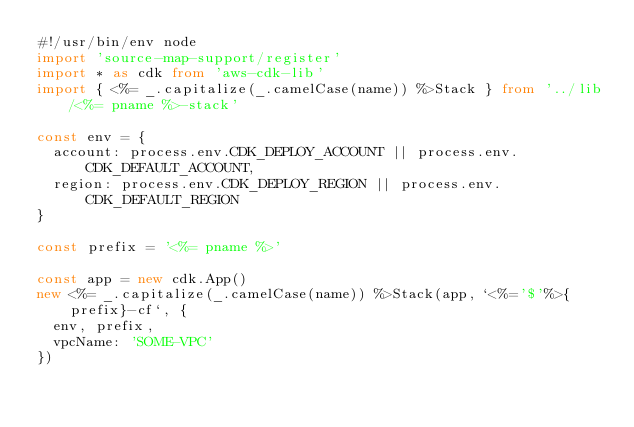<code> <loc_0><loc_0><loc_500><loc_500><_TypeScript_>#!/usr/bin/env node
import 'source-map-support/register'
import * as cdk from 'aws-cdk-lib'
import { <%= _.capitalize(_.camelCase(name)) %>Stack } from '../lib/<%= pname %>-stack'

const env = {
  account: process.env.CDK_DEPLOY_ACCOUNT || process.env.CDK_DEFAULT_ACCOUNT,
  region: process.env.CDK_DEPLOY_REGION || process.env.CDK_DEFAULT_REGION
}

const prefix = '<%= pname %>'

const app = new cdk.App()
new <%= _.capitalize(_.camelCase(name)) %>Stack(app, `<%='$'%>{prefix}-cf`, { 
  env, prefix,
  vpcName: 'SOME-VPC'
})</code> 